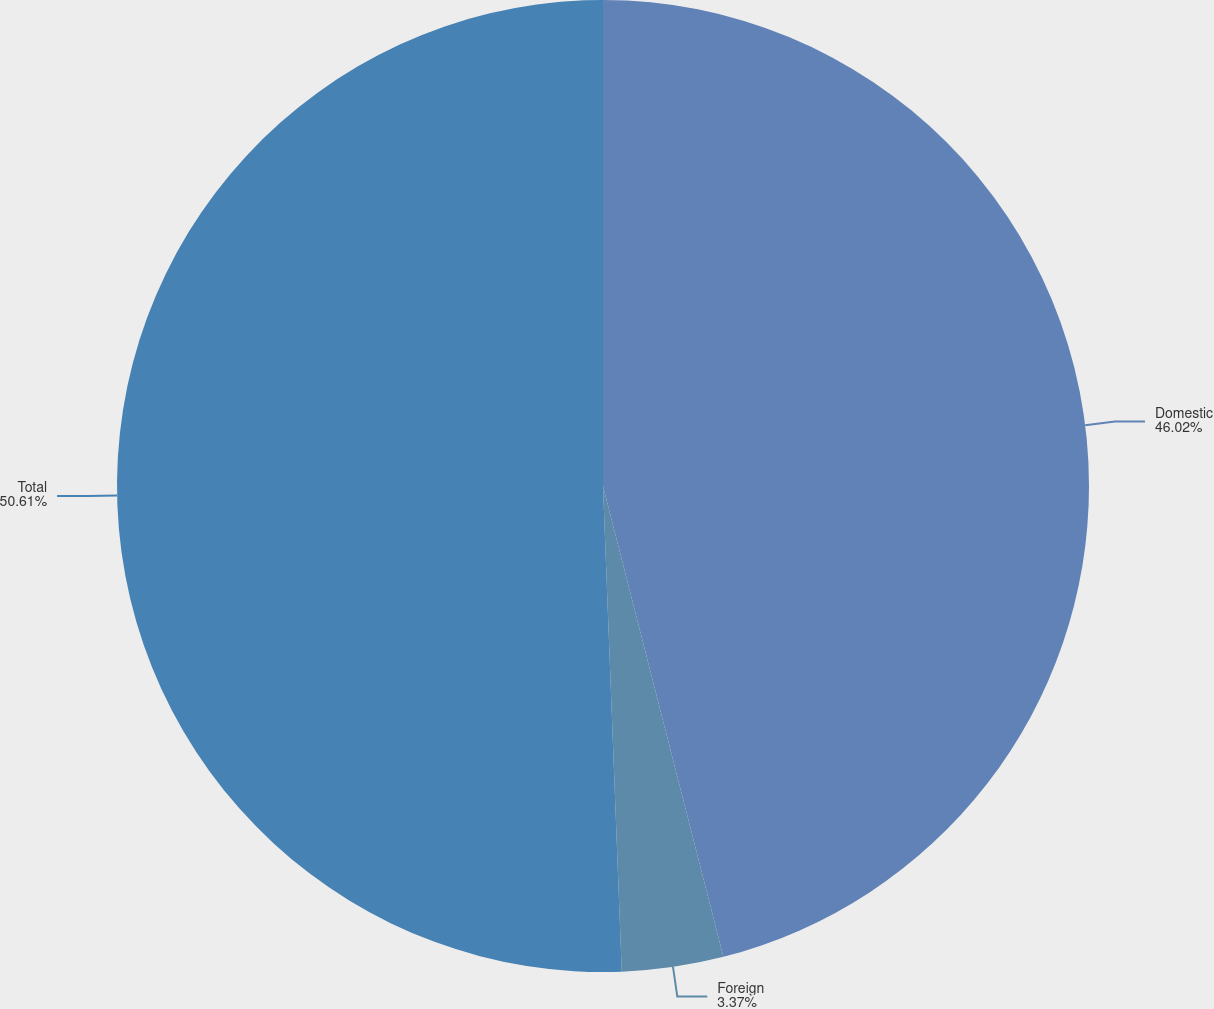Convert chart to OTSL. <chart><loc_0><loc_0><loc_500><loc_500><pie_chart><fcel>Domestic<fcel>Foreign<fcel>Total<nl><fcel>46.02%<fcel>3.37%<fcel>50.62%<nl></chart> 